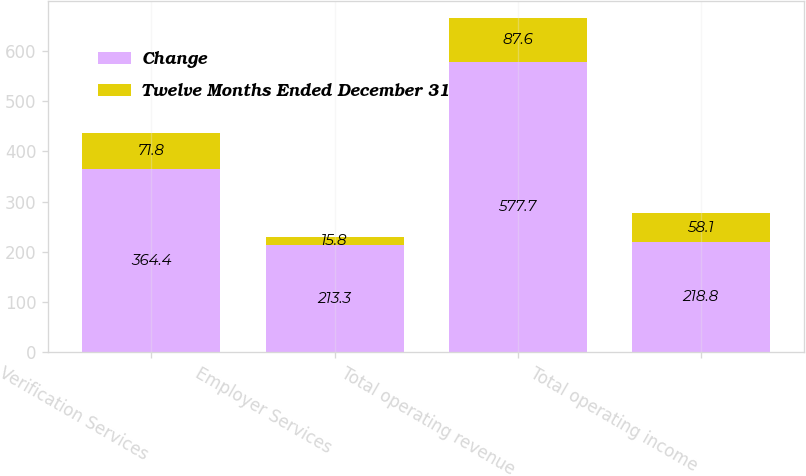Convert chart to OTSL. <chart><loc_0><loc_0><loc_500><loc_500><stacked_bar_chart><ecel><fcel>Verification Services<fcel>Employer Services<fcel>Total operating revenue<fcel>Total operating income<nl><fcel>Change<fcel>364.4<fcel>213.3<fcel>577.7<fcel>218.8<nl><fcel>Twelve Months Ended December 31<fcel>71.8<fcel>15.8<fcel>87.6<fcel>58.1<nl></chart> 